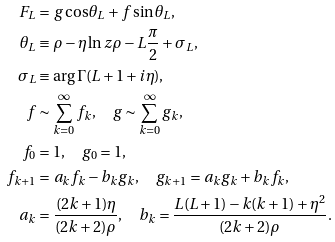Convert formula to latex. <formula><loc_0><loc_0><loc_500><loc_500>F _ { L } & = g \cos \theta _ { L } + f \sin \theta _ { L } , \\ \theta _ { L } & \equiv \rho - \eta \ln z \rho - L \frac { \pi } { 2 } + \sigma _ { L } , \\ \sigma _ { L } & \equiv \arg \Gamma ( L + 1 + i \eta ) , \\ f & \sim \sum ^ { \infty } _ { k = 0 } f _ { k } , \quad g \sim \sum ^ { \infty } _ { k = 0 } g _ { k } , \\ f _ { 0 } & = 1 , \quad g _ { 0 } = 1 , \\ f _ { k + 1 } & = a _ { k } f _ { k } - b _ { k } g _ { k } , \quad g _ { k + 1 } = a _ { k } g _ { k } + b _ { k } f _ { k } , \\ a _ { k } & = \frac { ( 2 k + 1 ) \eta } { ( 2 k + 2 ) \rho } , \quad b _ { k } = \frac { L ( L + 1 ) - k ( k + 1 ) + \eta ^ { 2 } } { ( 2 k + 2 ) \rho } .</formula> 